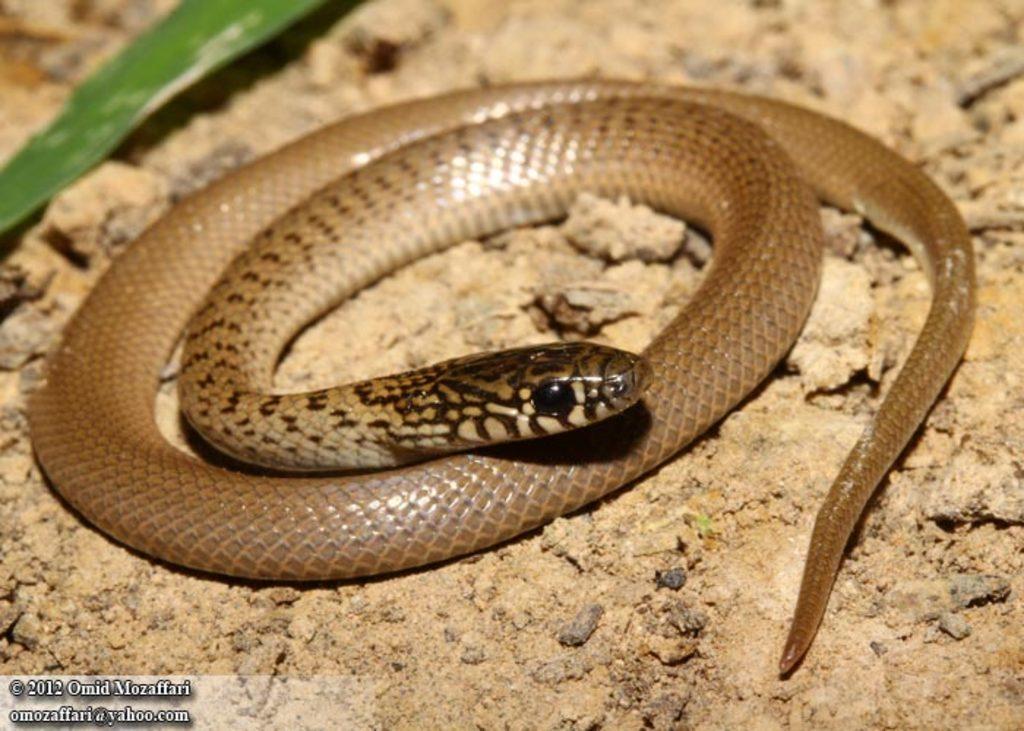Can you describe this image briefly? This image consists of a snake. It is in brown color. At the bottom, there is ground. To the left top, there is a leaf. 